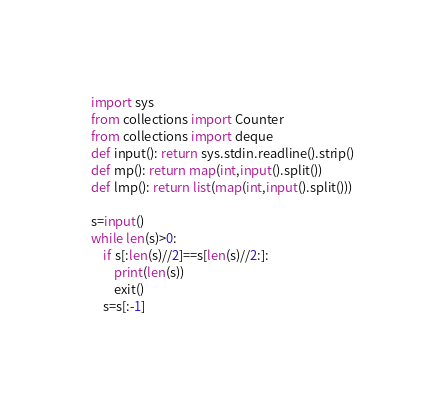<code> <loc_0><loc_0><loc_500><loc_500><_Python_>import sys
from collections import Counter
from collections import deque
def input(): return sys.stdin.readline().strip()
def mp(): return map(int,input().split())
def lmp(): return list(map(int,input().split()))

s=input()
while len(s)>0:
    if s[:len(s)//2]==s[len(s)//2:]:
        print(len(s))
        exit()
    s=s[:-1]
</code> 